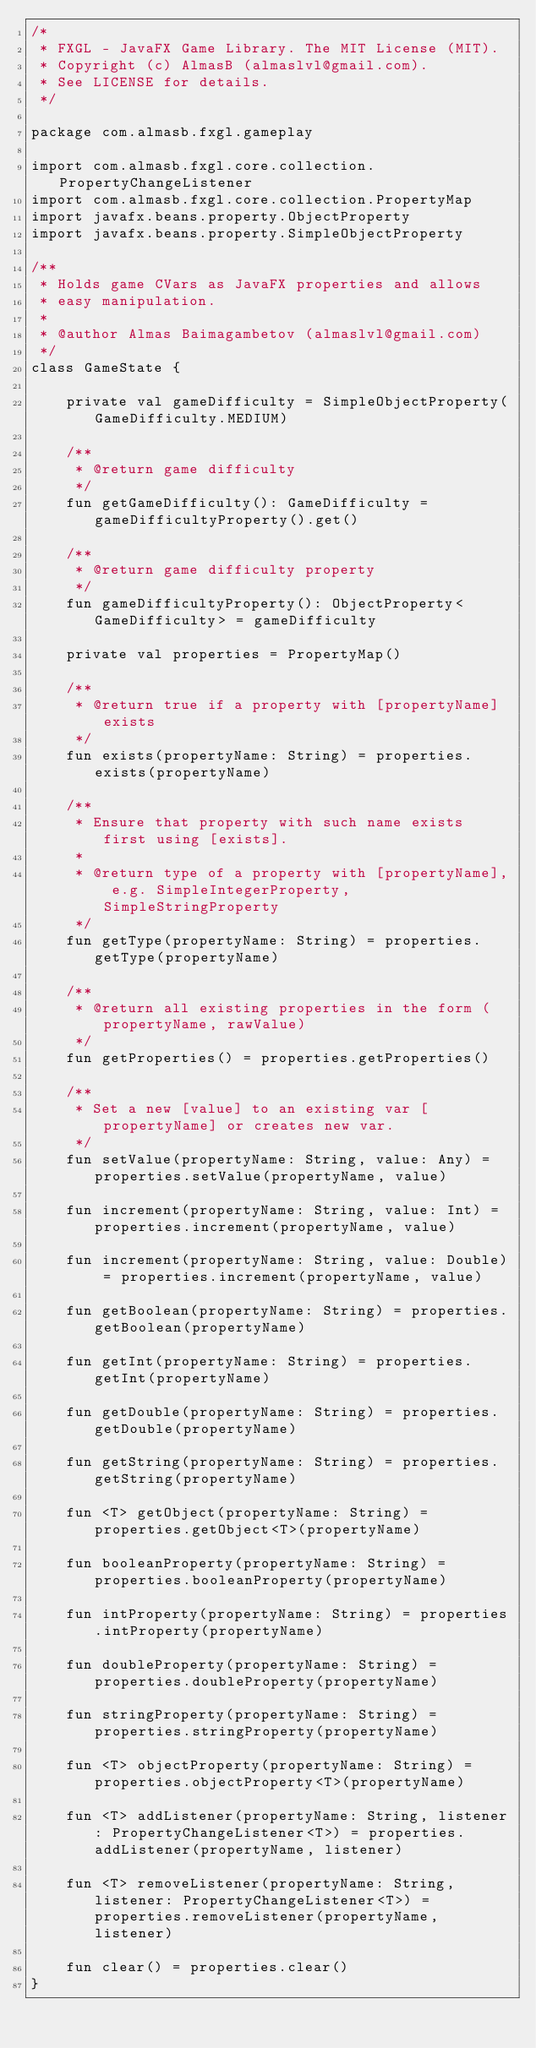<code> <loc_0><loc_0><loc_500><loc_500><_Kotlin_>/*
 * FXGL - JavaFX Game Library. The MIT License (MIT).
 * Copyright (c) AlmasB (almaslvl@gmail.com).
 * See LICENSE for details.
 */

package com.almasb.fxgl.gameplay

import com.almasb.fxgl.core.collection.PropertyChangeListener
import com.almasb.fxgl.core.collection.PropertyMap
import javafx.beans.property.ObjectProperty
import javafx.beans.property.SimpleObjectProperty

/**
 * Holds game CVars as JavaFX properties and allows
 * easy manipulation.
 *
 * @author Almas Baimagambetov (almaslvl@gmail.com)
 */
class GameState {

    private val gameDifficulty = SimpleObjectProperty(GameDifficulty.MEDIUM)

    /**
     * @return game difficulty
     */
    fun getGameDifficulty(): GameDifficulty = gameDifficultyProperty().get()

    /**
     * @return game difficulty property
     */
    fun gameDifficultyProperty(): ObjectProperty<GameDifficulty> = gameDifficulty

    private val properties = PropertyMap()

    /**
     * @return true if a property with [propertyName] exists
     */
    fun exists(propertyName: String) = properties.exists(propertyName)

    /**
     * Ensure that property with such name exists first using [exists].
     *
     * @return type of a property with [propertyName], e.g. SimpleIntegerProperty, SimpleStringProperty
     */
    fun getType(propertyName: String) = properties.getType(propertyName)

    /**
     * @return all existing properties in the form (propertyName, rawValue)
     */
    fun getProperties() = properties.getProperties()

    /**
     * Set a new [value] to an existing var [propertyName] or creates new var.
     */
    fun setValue(propertyName: String, value: Any) = properties.setValue(propertyName, value)

    fun increment(propertyName: String, value: Int) = properties.increment(propertyName, value)

    fun increment(propertyName: String, value: Double) = properties.increment(propertyName, value)

    fun getBoolean(propertyName: String) = properties.getBoolean(propertyName)

    fun getInt(propertyName: String) = properties.getInt(propertyName)

    fun getDouble(propertyName: String) = properties.getDouble(propertyName)

    fun getString(propertyName: String) = properties.getString(propertyName)

    fun <T> getObject(propertyName: String) = properties.getObject<T>(propertyName)

    fun booleanProperty(propertyName: String) = properties.booleanProperty(propertyName)

    fun intProperty(propertyName: String) = properties.intProperty(propertyName)

    fun doubleProperty(propertyName: String) = properties.doubleProperty(propertyName)

    fun stringProperty(propertyName: String) = properties.stringProperty(propertyName)

    fun <T> objectProperty(propertyName: String) = properties.objectProperty<T>(propertyName)

    fun <T> addListener(propertyName: String, listener: PropertyChangeListener<T>) = properties.addListener(propertyName, listener)

    fun <T> removeListener(propertyName: String, listener: PropertyChangeListener<T>) = properties.removeListener(propertyName, listener)

    fun clear() = properties.clear()
}</code> 